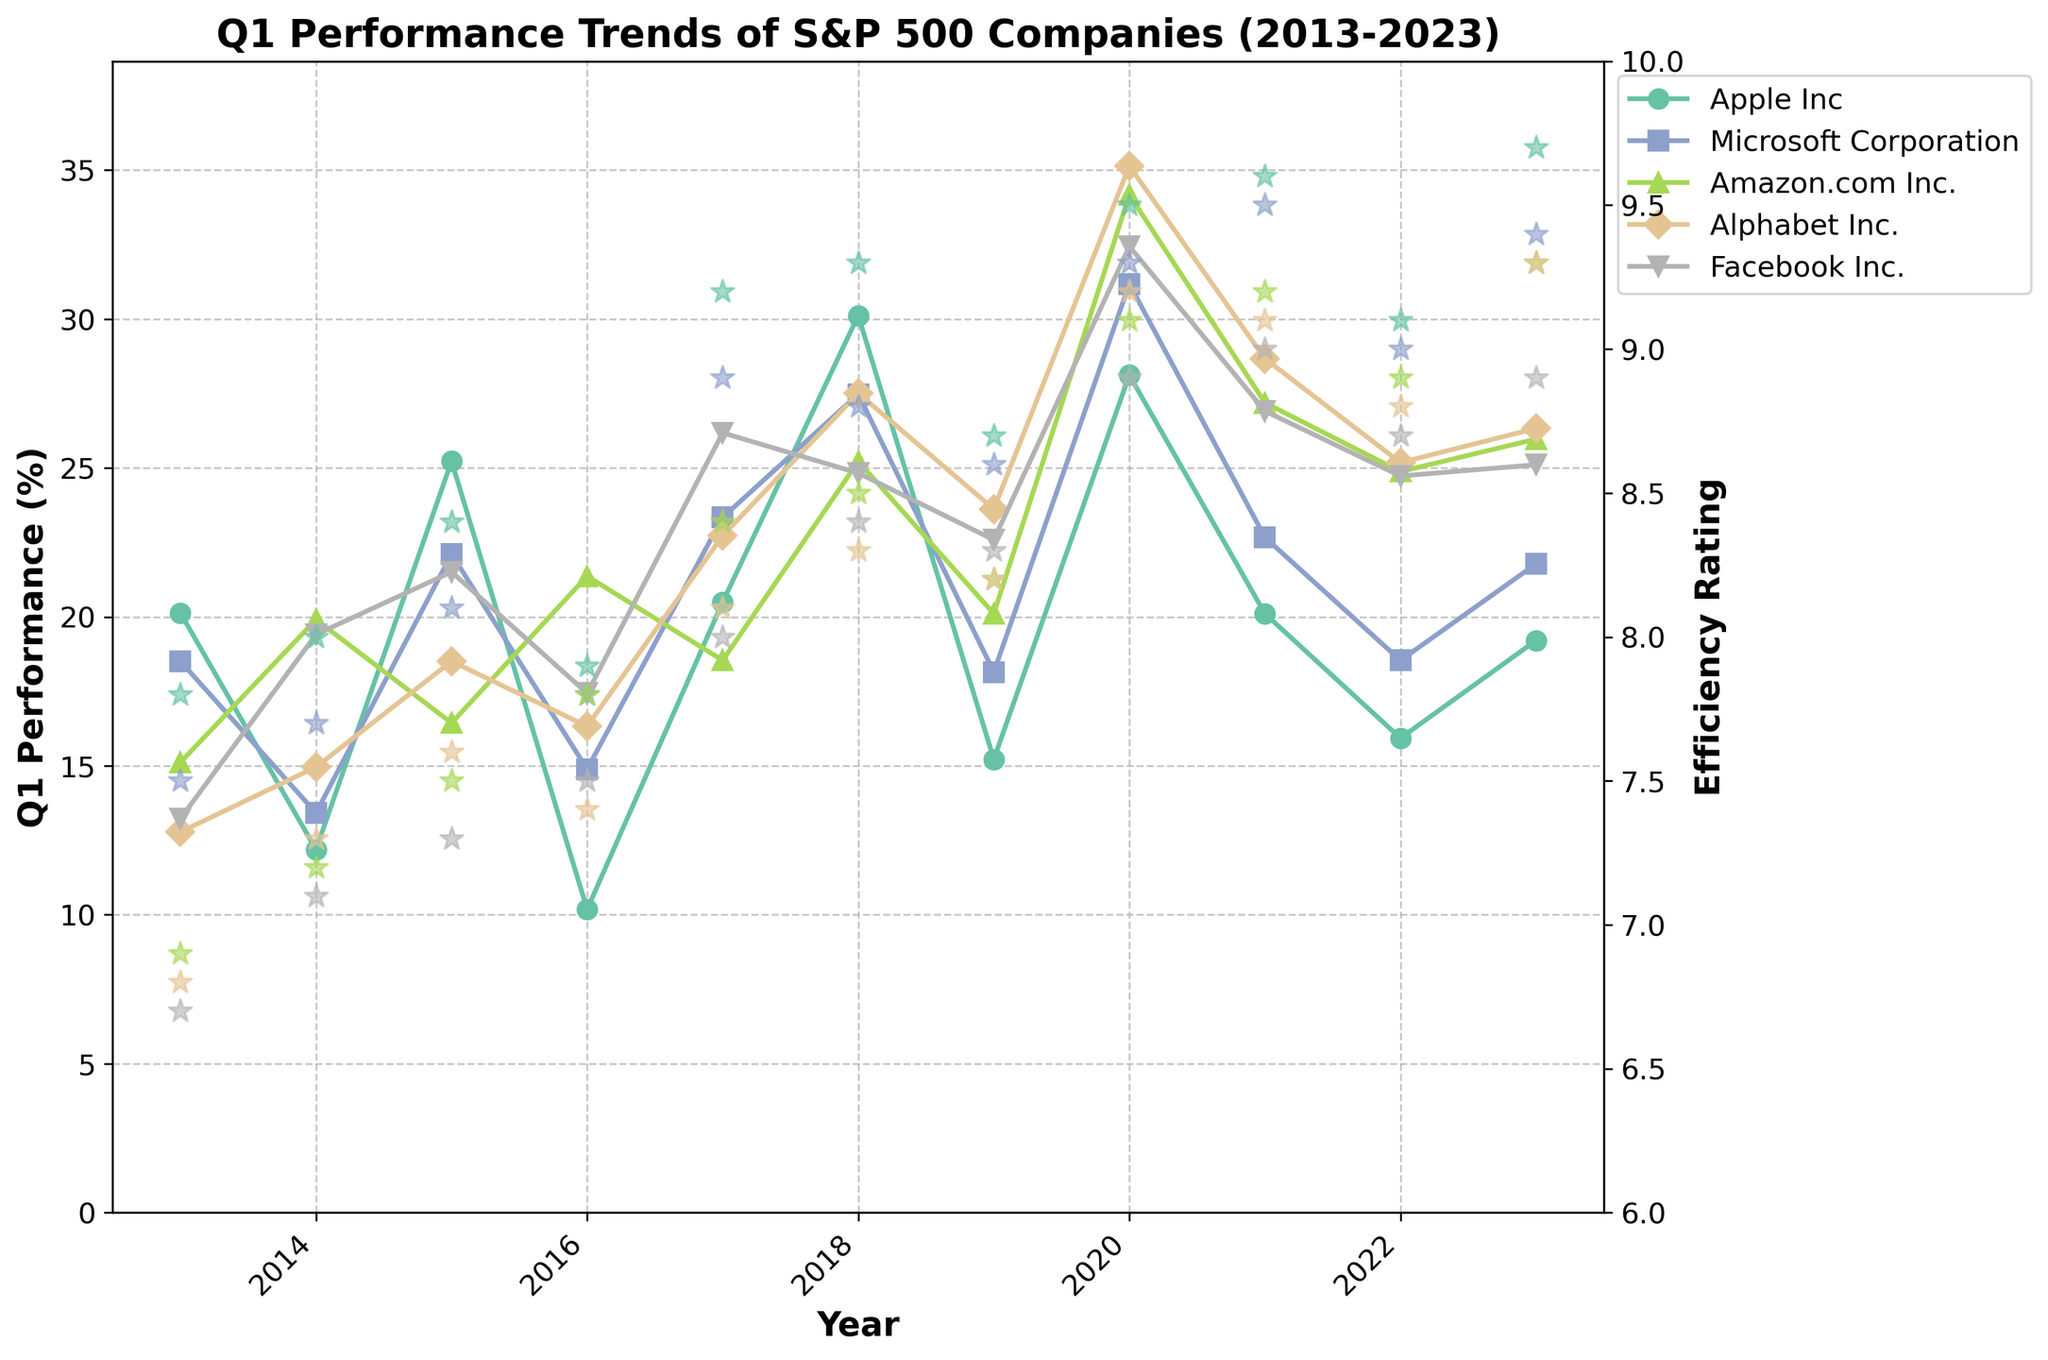What is the title of the plot? The title is located at the top of the plot, providing a summary of the visual data presented. It reads "Q1 Performance Trends of S&P 500 Companies (2013-2023)".
Answer: Q1 Performance Trends of S&P 500 Companies (2013-2023) What is the Y-axis label for the primary axis on the left? The primary Y-axis label on the left side of the plot indicates the metric being measured, which is "Q1 Performance (%)".
Answer: Q1 Performance (%) What is the trend for Apple's Q1 Performance from 2013 to 2023? Looking at the line corresponding to Apple Inc. in the plot, we can see how the Q1 Performance values change from 2013 to 2023. Note the rise and fall over the years.
Answer: Fluctuating with an overall upward trend, peaking in 2018 Which company had the highest Q1 Performance in any year and what was that value? By identifying the line that reaches the highest point on the Q1 Performance (%) axis, we find that Alphabet Inc. had the highest Q1 Performance in 2020, reaching approximately 35.14%.
Answer: Alphabet Inc., 35.14% in 2020 How does Microsoft's Q1 Performance in 2020 compare to its Performance in 2013? Examine the two specific points on Microsoft's line in the plot: one for 2020 and one for 2013. Compare their values on the Y-axis (Q1 Performance (%)).
Answer: 31.18% in 2020, higher than 18.51% in 2013 What is the average Q1 Performance for Facebook Inc. from 2018 to 2023? Identify Facebook Inc.'s Q1 Performance values for the years 2018 through 2023, sum these values, and then divide by the number of years (6). The values are 24.83, 22.59, 32.44, 26.91, 24.73, and 25.11.
Answer: (24.83 + 22.59 + 32.44 + 26.91 + 24.73 + 25.11) / 6 ≈ 26.10 Which company shows the most consistent Efficiency Rating from 2013 to 2023? By looking at the Efficiency Rating scatter plots, identify the company with the least variation in Efficiency Ratings over the years. Consistency is shown by closely grouped points.
Answer: Apple Inc How does the Efficiency Rating of Amazon.com Inc. in 2020 compare to its Q1 Performance in the same year? Locate Amazon.com Inc.'s Efficiency Rating for 2020 and compare it to its Q1 Performance for the same year. The values are both present on their respective Y-axes.
Answer: 9.1 Efficiency Rating and 34.17% Q1 Performance Between Alphabet Inc. and Facebook Inc., which company had a higher Q1 Performance in 2017? Find the Q1 Performance values for Alphabet Inc. and Facebook Inc. in the year 2017 and compare them.
Answer: Alphabet Inc. with 22.73% What can you infer about the relationship between Q1 Performance and Efficiency Rating for Microsoft Corporation in 2021? In 2021, observe Microsoft's Q1 Performance and Efficiency Rating. Note any correlation pattern between these two metrics for that year.
Answer: High Q1 Performance of 22.67% and Efficiency Rating of 9.5, suggesting a strong positive relationship 